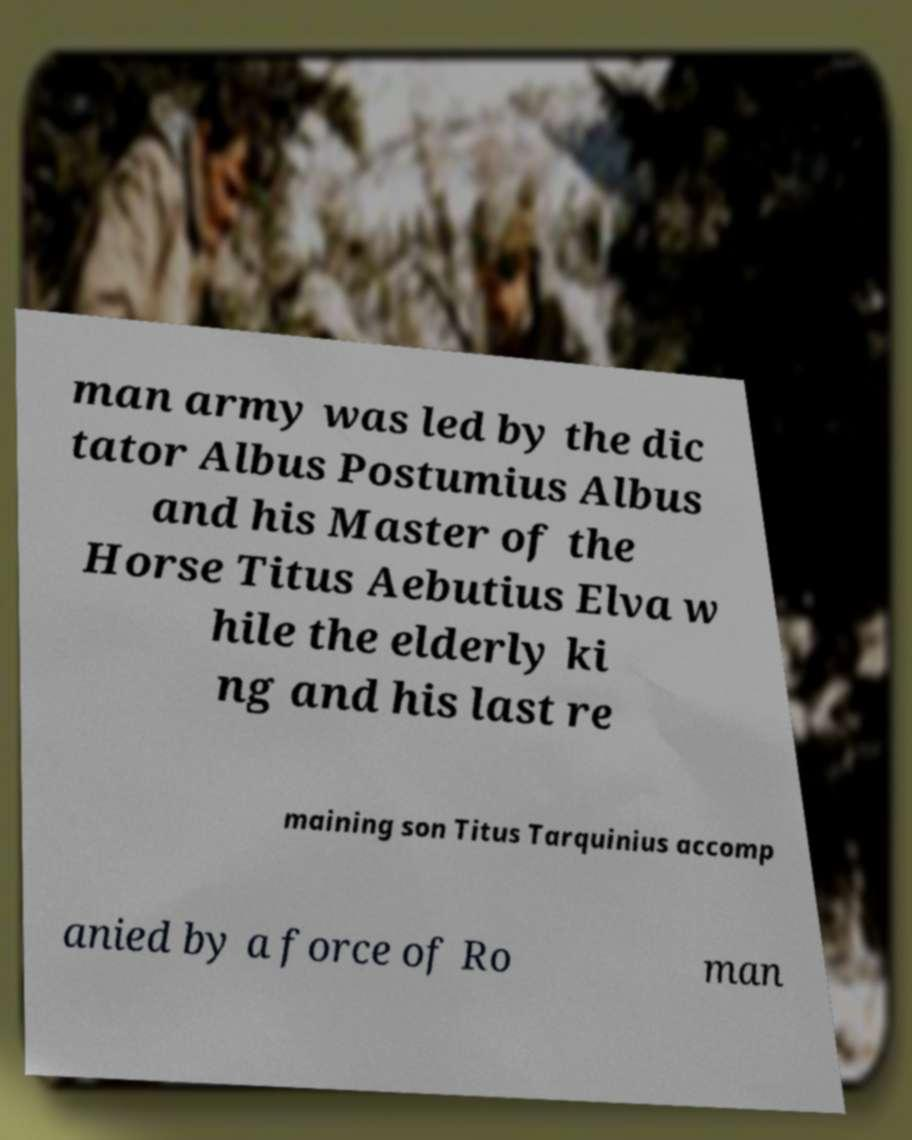I need the written content from this picture converted into text. Can you do that? man army was led by the dic tator Albus Postumius Albus and his Master of the Horse Titus Aebutius Elva w hile the elderly ki ng and his last re maining son Titus Tarquinius accomp anied by a force of Ro man 